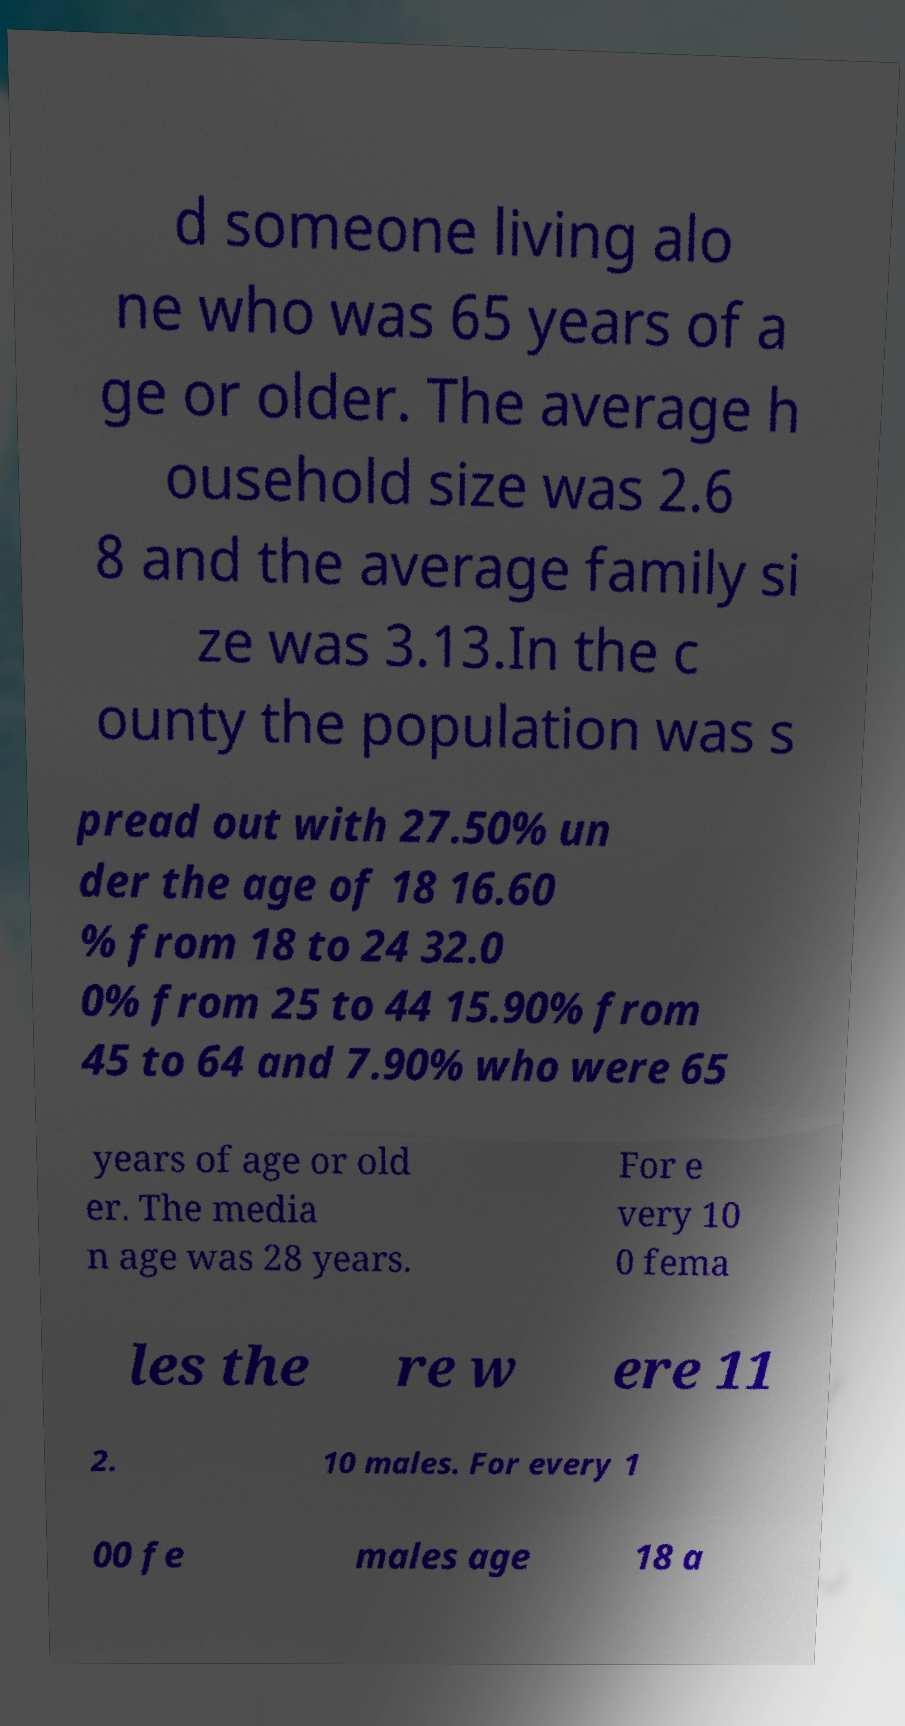Can you read and provide the text displayed in the image?This photo seems to have some interesting text. Can you extract and type it out for me? d someone living alo ne who was 65 years of a ge or older. The average h ousehold size was 2.6 8 and the average family si ze was 3.13.In the c ounty the population was s pread out with 27.50% un der the age of 18 16.60 % from 18 to 24 32.0 0% from 25 to 44 15.90% from 45 to 64 and 7.90% who were 65 years of age or old er. The media n age was 28 years. For e very 10 0 fema les the re w ere 11 2. 10 males. For every 1 00 fe males age 18 a 